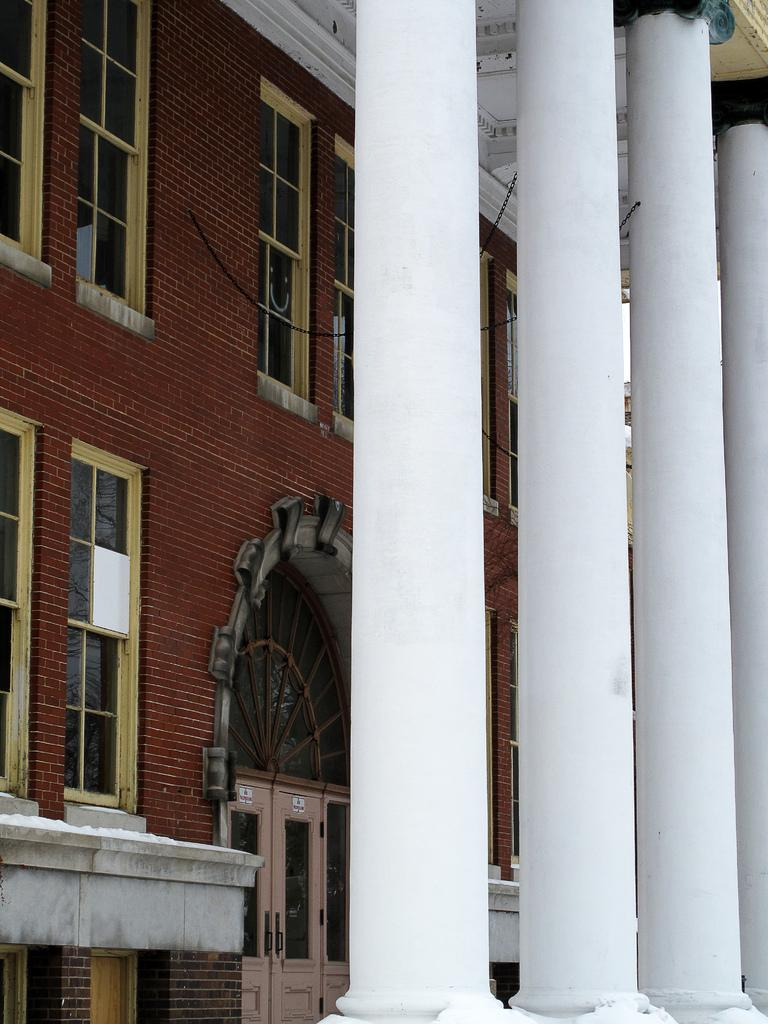What is the main subject of the image? The main subject of the image is a building. Can you describe the building's features? The building has pillars and windows. Is there any smoke coming from the building in the image? There is no mention of smoke in the provided facts, and therefore it cannot be determined from the image. 